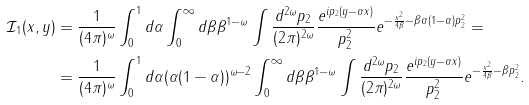<formula> <loc_0><loc_0><loc_500><loc_500>\mathcal { I } _ { 1 } ( x , y ) & = \frac { 1 } { ( 4 \pi ) ^ { \omega } } \int _ { 0 } ^ { 1 } d \alpha \int _ { 0 } ^ { \infty } d \beta \beta ^ { 1 - \omega } \int \frac { d ^ { 2 \omega } p _ { 2 } } { ( 2 \pi ) ^ { 2 \omega } } \frac { e ^ { i p _ { 2 } ( y - \alpha x ) } } { p _ { 2 } ^ { 2 } } { e ^ { - \frac { { x } ^ { 2 } } { 4 \beta } - \beta \alpha ( 1 - \alpha ) p _ { 2 } ^ { 2 } } } = \\ & = \frac { 1 } { ( 4 \pi ) ^ { \omega } } \int _ { 0 } ^ { 1 } d \alpha ( \alpha ( 1 - \alpha ) ) ^ { \omega - 2 } \int _ { 0 } ^ { \infty } d \beta \beta ^ { 1 - \omega } \int \frac { d ^ { 2 \omega } p _ { 2 } } { ( 2 \pi ) ^ { 2 \omega } } \frac { e ^ { i p _ { 2 } ( y - \alpha x ) } } { p _ { 2 } ^ { 2 } } { e ^ { - \frac { { x } ^ { 2 } } { 4 \beta } - \beta p _ { 2 } ^ { 2 } } } .</formula> 